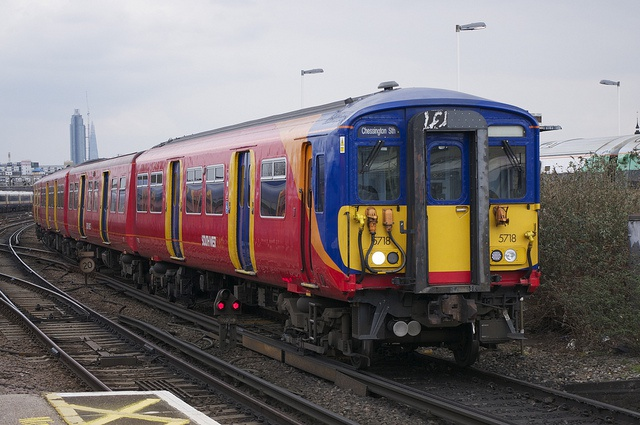Describe the objects in this image and their specific colors. I can see a train in lightgray, black, gray, navy, and maroon tones in this image. 